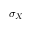Convert formula to latex. <formula><loc_0><loc_0><loc_500><loc_500>\sigma _ { X }</formula> 